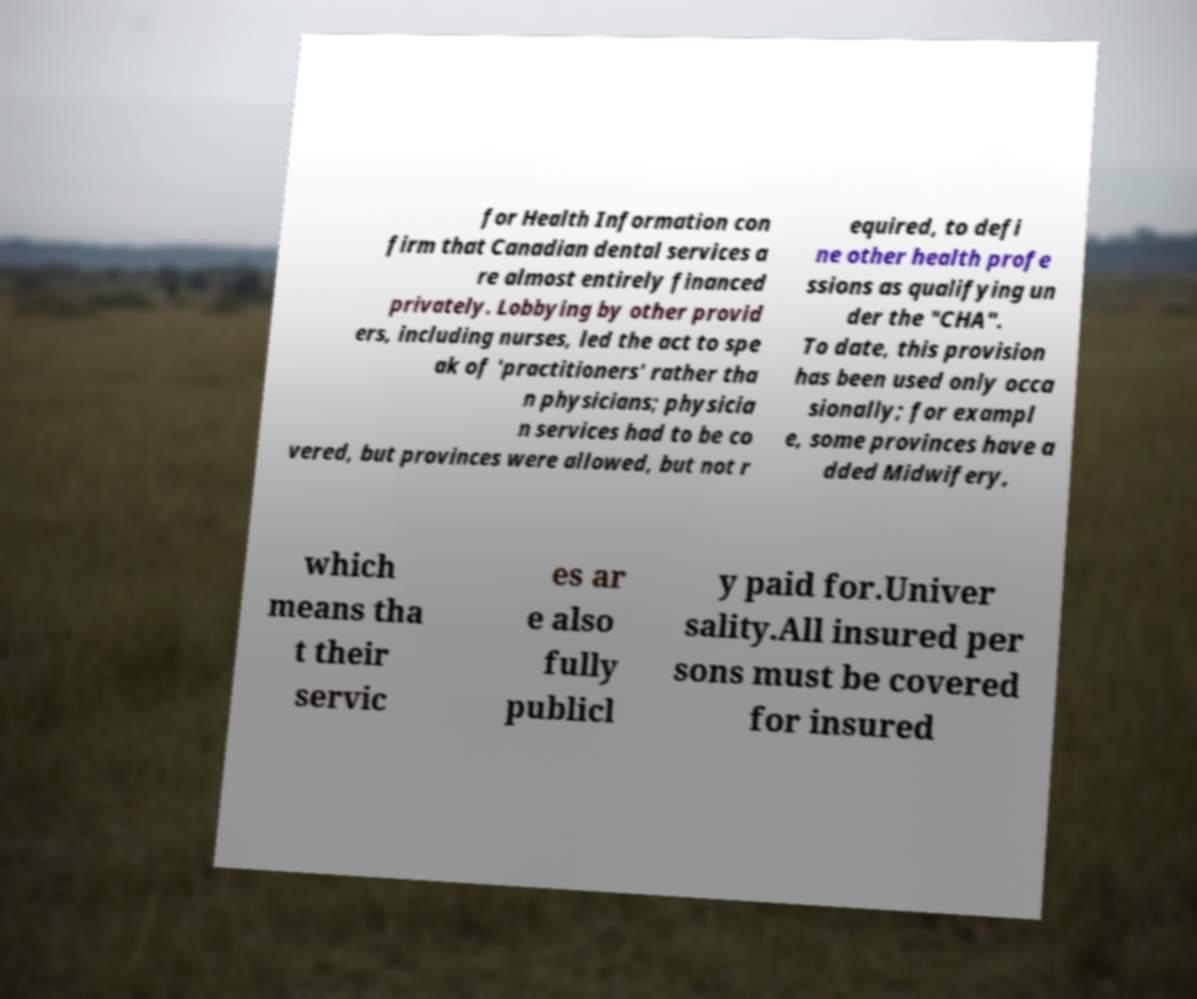Please identify and transcribe the text found in this image. for Health Information con firm that Canadian dental services a re almost entirely financed privately. Lobbying by other provid ers, including nurses, led the act to spe ak of 'practitioners' rather tha n physicians; physicia n services had to be co vered, but provinces were allowed, but not r equired, to defi ne other health profe ssions as qualifying un der the "CHA". To date, this provision has been used only occa sionally; for exampl e, some provinces have a dded Midwifery, which means tha t their servic es ar e also fully publicl y paid for.Univer sality.All insured per sons must be covered for insured 